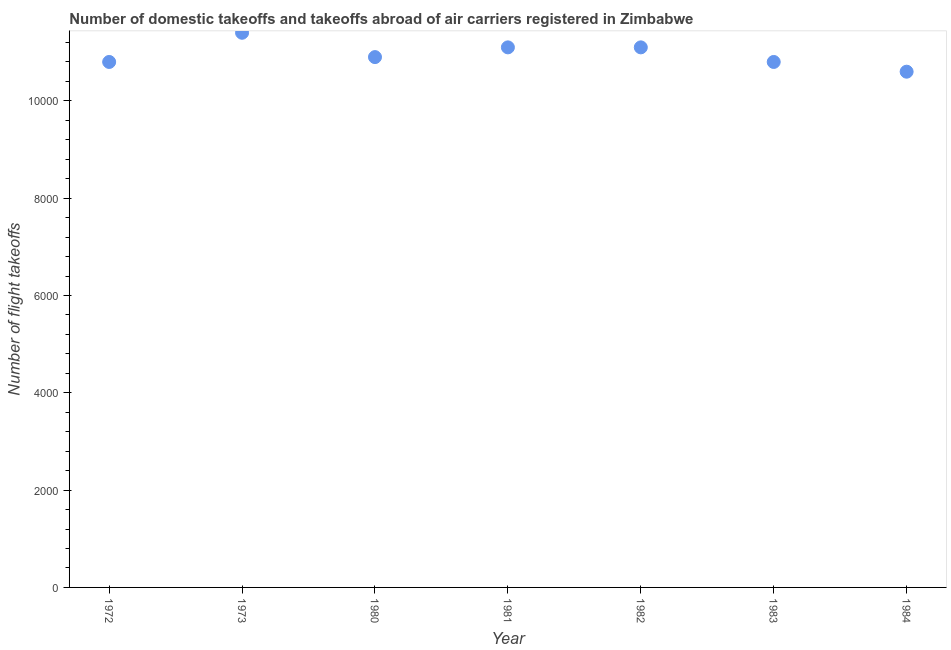What is the number of flight takeoffs in 1983?
Keep it short and to the point. 1.08e+04. Across all years, what is the maximum number of flight takeoffs?
Your answer should be compact. 1.14e+04. Across all years, what is the minimum number of flight takeoffs?
Keep it short and to the point. 1.06e+04. In which year was the number of flight takeoffs maximum?
Provide a short and direct response. 1973. What is the sum of the number of flight takeoffs?
Ensure brevity in your answer.  7.67e+04. What is the difference between the number of flight takeoffs in 1980 and 1982?
Offer a very short reply. -200. What is the average number of flight takeoffs per year?
Ensure brevity in your answer.  1.10e+04. What is the median number of flight takeoffs?
Provide a short and direct response. 1.09e+04. What is the ratio of the number of flight takeoffs in 1981 to that in 1984?
Make the answer very short. 1.05. What is the difference between the highest and the second highest number of flight takeoffs?
Offer a very short reply. 300. Is the sum of the number of flight takeoffs in 1973 and 1980 greater than the maximum number of flight takeoffs across all years?
Your answer should be compact. Yes. What is the difference between the highest and the lowest number of flight takeoffs?
Keep it short and to the point. 800. In how many years, is the number of flight takeoffs greater than the average number of flight takeoffs taken over all years?
Provide a short and direct response. 3. How many years are there in the graph?
Offer a very short reply. 7. Does the graph contain any zero values?
Your response must be concise. No. Does the graph contain grids?
Provide a succinct answer. No. What is the title of the graph?
Your answer should be very brief. Number of domestic takeoffs and takeoffs abroad of air carriers registered in Zimbabwe. What is the label or title of the X-axis?
Give a very brief answer. Year. What is the label or title of the Y-axis?
Your response must be concise. Number of flight takeoffs. What is the Number of flight takeoffs in 1972?
Your answer should be very brief. 1.08e+04. What is the Number of flight takeoffs in 1973?
Your answer should be very brief. 1.14e+04. What is the Number of flight takeoffs in 1980?
Your answer should be very brief. 1.09e+04. What is the Number of flight takeoffs in 1981?
Ensure brevity in your answer.  1.11e+04. What is the Number of flight takeoffs in 1982?
Make the answer very short. 1.11e+04. What is the Number of flight takeoffs in 1983?
Your answer should be very brief. 1.08e+04. What is the Number of flight takeoffs in 1984?
Give a very brief answer. 1.06e+04. What is the difference between the Number of flight takeoffs in 1972 and 1973?
Offer a terse response. -600. What is the difference between the Number of flight takeoffs in 1972 and 1980?
Your answer should be very brief. -100. What is the difference between the Number of flight takeoffs in 1972 and 1981?
Make the answer very short. -300. What is the difference between the Number of flight takeoffs in 1972 and 1982?
Give a very brief answer. -300. What is the difference between the Number of flight takeoffs in 1972 and 1984?
Make the answer very short. 200. What is the difference between the Number of flight takeoffs in 1973 and 1981?
Give a very brief answer. 300. What is the difference between the Number of flight takeoffs in 1973 and 1982?
Your response must be concise. 300. What is the difference between the Number of flight takeoffs in 1973 and 1983?
Make the answer very short. 600. What is the difference between the Number of flight takeoffs in 1973 and 1984?
Offer a terse response. 800. What is the difference between the Number of flight takeoffs in 1980 and 1981?
Offer a terse response. -200. What is the difference between the Number of flight takeoffs in 1980 and 1982?
Keep it short and to the point. -200. What is the difference between the Number of flight takeoffs in 1980 and 1984?
Your response must be concise. 300. What is the difference between the Number of flight takeoffs in 1981 and 1982?
Provide a short and direct response. 0. What is the difference between the Number of flight takeoffs in 1981 and 1983?
Offer a terse response. 300. What is the difference between the Number of flight takeoffs in 1981 and 1984?
Offer a very short reply. 500. What is the difference between the Number of flight takeoffs in 1982 and 1983?
Make the answer very short. 300. What is the ratio of the Number of flight takeoffs in 1972 to that in 1973?
Provide a succinct answer. 0.95. What is the ratio of the Number of flight takeoffs in 1972 to that in 1983?
Provide a succinct answer. 1. What is the ratio of the Number of flight takeoffs in 1973 to that in 1980?
Your answer should be very brief. 1.05. What is the ratio of the Number of flight takeoffs in 1973 to that in 1982?
Provide a succinct answer. 1.03. What is the ratio of the Number of flight takeoffs in 1973 to that in 1983?
Keep it short and to the point. 1.06. What is the ratio of the Number of flight takeoffs in 1973 to that in 1984?
Ensure brevity in your answer.  1.07. What is the ratio of the Number of flight takeoffs in 1980 to that in 1984?
Your answer should be compact. 1.03. What is the ratio of the Number of flight takeoffs in 1981 to that in 1982?
Make the answer very short. 1. What is the ratio of the Number of flight takeoffs in 1981 to that in 1983?
Provide a short and direct response. 1.03. What is the ratio of the Number of flight takeoffs in 1981 to that in 1984?
Make the answer very short. 1.05. What is the ratio of the Number of flight takeoffs in 1982 to that in 1983?
Provide a succinct answer. 1.03. What is the ratio of the Number of flight takeoffs in 1982 to that in 1984?
Your response must be concise. 1.05. What is the ratio of the Number of flight takeoffs in 1983 to that in 1984?
Give a very brief answer. 1.02. 